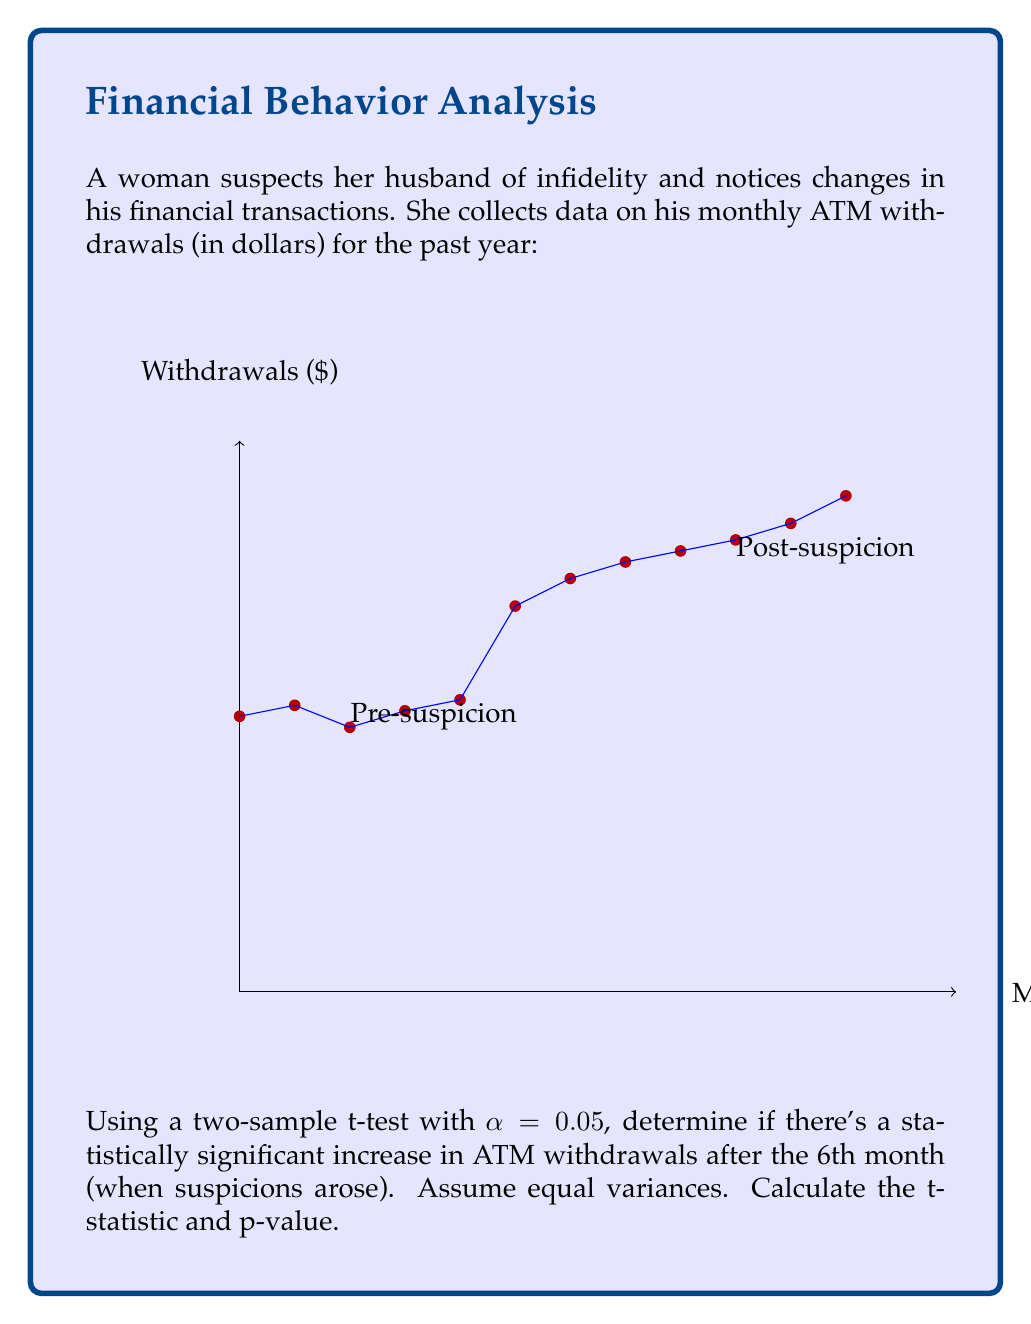Teach me how to tackle this problem. Let's approach this step-by-step:

1) First, we need to split the data into two groups:
   Pre-suspicion: $\{500, 520, 480, 510, 530, 700\}$
   Post-suspicion: $\{750, 780, 800, 820, 850, 900\}$

2) Calculate means for each group:
   $\bar{X}_1 = \frac{500 + 520 + 480 + 510 + 530 + 700}{6} = 540$
   $\bar{X}_2 = \frac{750 + 780 + 800 + 820 + 850 + 900}{6} = 816.67$

3) Calculate the pooled standard deviation:
   $s_p = \sqrt{\frac{\sum_{i=1}^{n_1} (X_{1i} - \bar{X}_1)^2 + \sum_{i=1}^{n_2} (X_{2i} - \bar{X}_2)^2}{n_1 + n_2 - 2}}$
   
   After calculations: $s_p \approx 131.27$

4) Calculate the t-statistic:
   $t = \frac{\bar{X}_2 - \bar{X}_1}{s_p \sqrt{\frac{2}{n}}} = \frac{816.67 - 540}{131.27 \sqrt{\frac{2}{6}}} \approx 4.58$

5) Degrees of freedom: $df = n_1 + n_2 - 2 = 6 + 6 - 2 = 10$

6) For $\alpha = 0.05$ and $df = 10$, the critical t-value is approximately 2.228 (two-tailed).

7) Since $|t| > 2.228$, we reject the null hypothesis.

8) Calculate p-value:
   Using a t-distribution calculator with $df = 10$ and $t = 4.58$, we get $p \approx 0.001$
Answer: $t \approx 4.58$, $p \approx 0.001$. Statistically significant increase. 